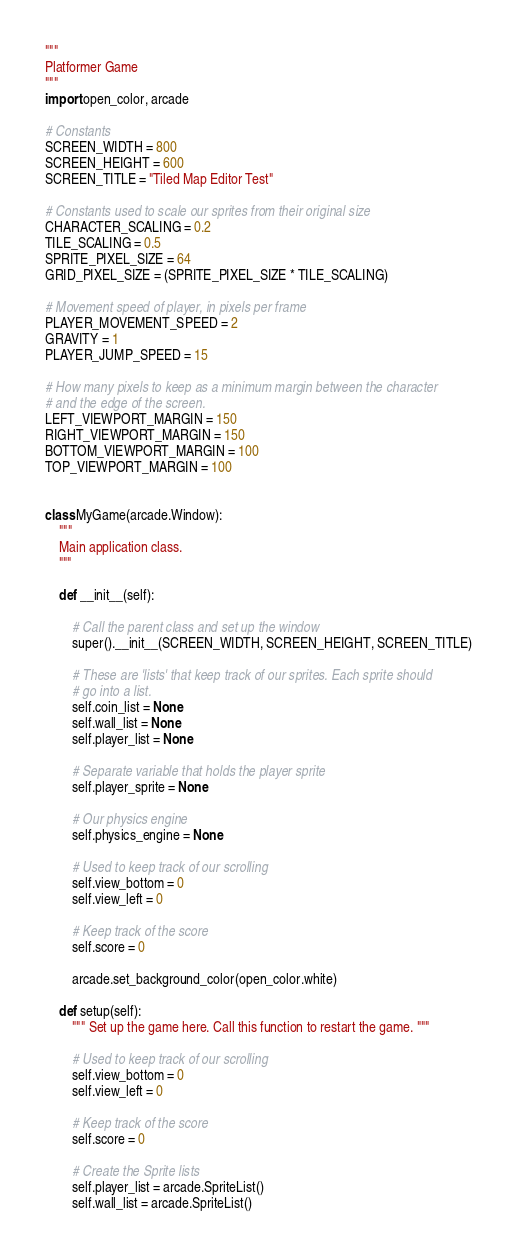Convert code to text. <code><loc_0><loc_0><loc_500><loc_500><_Python_>"""
Platformer Game
"""
import open_color, arcade

# Constants
SCREEN_WIDTH = 800
SCREEN_HEIGHT = 600
SCREEN_TITLE = "Tiled Map Editor Test"

# Constants used to scale our sprites from their original size
CHARACTER_SCALING = 0.2
TILE_SCALING = 0.5
SPRITE_PIXEL_SIZE = 64
GRID_PIXEL_SIZE = (SPRITE_PIXEL_SIZE * TILE_SCALING)

# Movement speed of player, in pixels per frame
PLAYER_MOVEMENT_SPEED = 2
GRAVITY = 1
PLAYER_JUMP_SPEED = 15

# How many pixels to keep as a minimum margin between the character
# and the edge of the screen.
LEFT_VIEWPORT_MARGIN = 150
RIGHT_VIEWPORT_MARGIN = 150
BOTTOM_VIEWPORT_MARGIN = 100
TOP_VIEWPORT_MARGIN = 100


class MyGame(arcade.Window):
    """
    Main application class.
    """

    def __init__(self):

        # Call the parent class and set up the window
        super().__init__(SCREEN_WIDTH, SCREEN_HEIGHT, SCREEN_TITLE)

        # These are 'lists' that keep track of our sprites. Each sprite should
        # go into a list.
        self.coin_list = None
        self.wall_list = None
        self.player_list = None

        # Separate variable that holds the player sprite
        self.player_sprite = None

        # Our physics engine
        self.physics_engine = None

        # Used to keep track of our scrolling
        self.view_bottom = 0
        self.view_left = 0

        # Keep track of the score
        self.score = 0

        arcade.set_background_color(open_color.white)

    def setup(self):
        """ Set up the game here. Call this function to restart the game. """

        # Used to keep track of our scrolling
        self.view_bottom = 0
        self.view_left = 0

        # Keep track of the score
        self.score = 0

        # Create the Sprite lists
        self.player_list = arcade.SpriteList()
        self.wall_list = arcade.SpriteList()</code> 